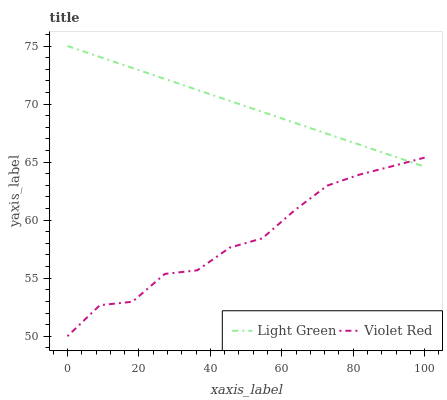Does Light Green have the minimum area under the curve?
Answer yes or no. No. Is Light Green the roughest?
Answer yes or no. No. Does Light Green have the lowest value?
Answer yes or no. No. 